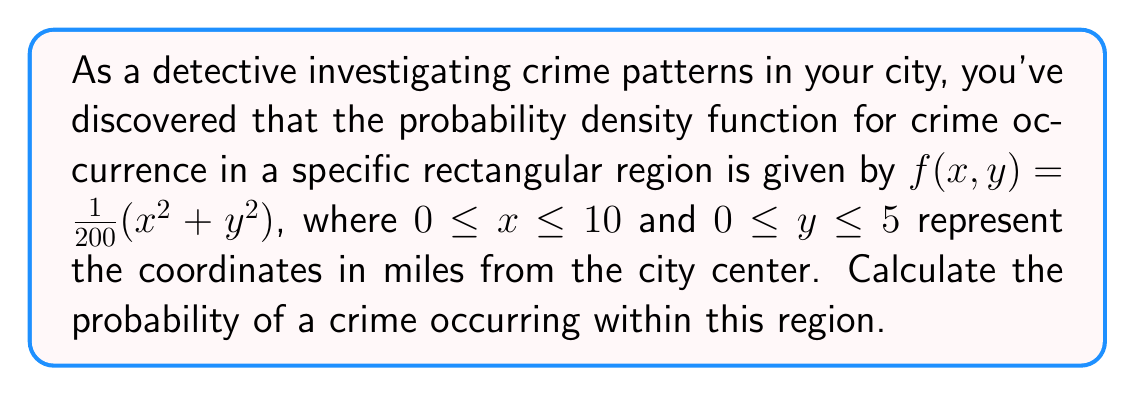Teach me how to tackle this problem. To solve this problem, we need to evaluate a double integral of the given probability density function over the specified region. Here's a step-by-step approach:

1) The probability of an event occurring in a region $R$ is given by the integral of the probability density function over that region:

   $P = \iint_R f(x,y) dA$

2) In this case, $f(x,y) = \frac{1}{200}(x^2 + y^2)$, and the region $R$ is defined by $0 \leq x \leq 10$ and $0 \leq y \leq 5$.

3) We can set up the double integral as follows:

   $P = \int_0^5 \int_0^{10} \frac{1}{200}(x^2 + y^2) dx dy$

4) Let's evaluate the inner integral first (with respect to x):

   $P = \int_0^5 \left[ \frac{1}{200}(\frac{x^3}{3} + xy^2) \right]_0^{10} dy$

5) Evaluating the inner integral:

   $P = \int_0^5 \left[ \frac{1}{200}(\frac{1000}{3} + 10y^2) - 0 \right] dy$
   
   $P = \int_0^5 \left[ \frac{1000}{600} + \frac{y^2}{20} \right] dy$

6) Now let's evaluate the outer integral:

   $P = \left[ \frac{1000y}{600} + \frac{y^3}{60} \right]_0^5$

7) Evaluating the outer integral:

   $P = \left( \frac{1000 \cdot 5}{600} + \frac{5^3}{60} \right) - \left( 0 + 0 \right)$
   
   $P = \frac{5000}{600} + \frac{125}{60} = \frac{500}{60} + \frac{125}{60} = \frac{625}{60}$

Therefore, the probability of a crime occurring in this region is $\frac{625}{60}$.
Answer: $\frac{625}{60}$ or approximately $10.42\%$ 